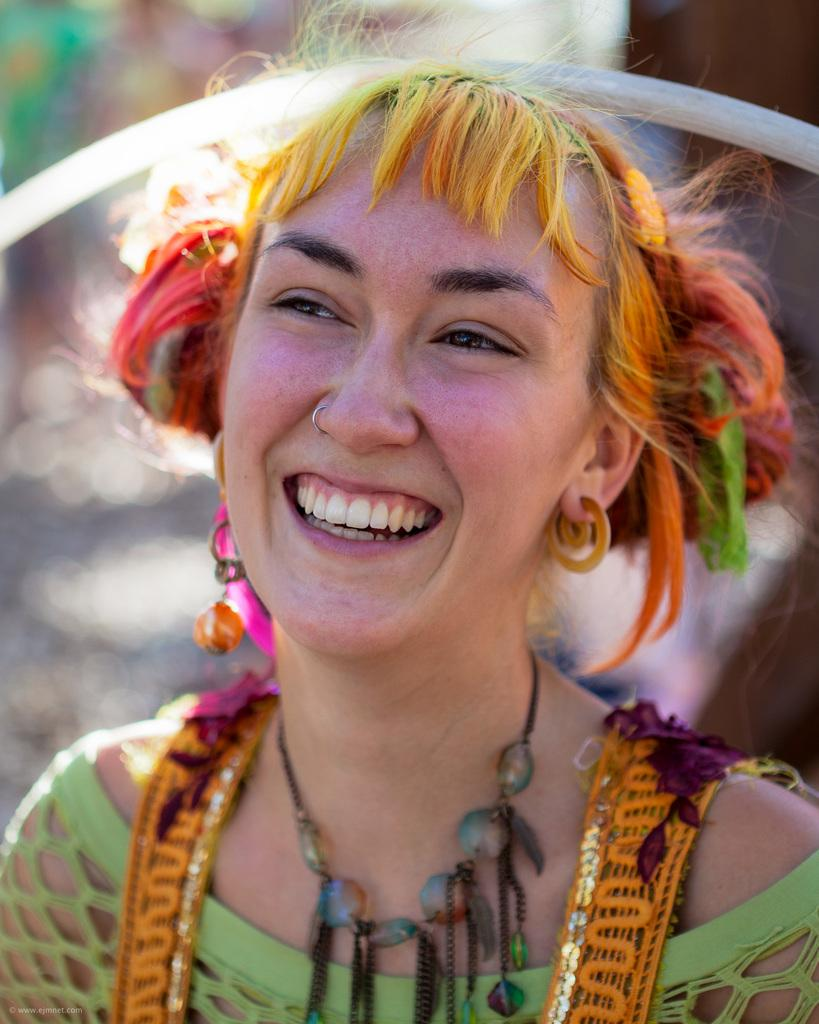Who is present in the image? There is a woman in the image. What is the woman's facial expression? The woman is smiling. What accessory is the woman wearing? The woman is wearing a necklace. Are there any other accessories or clothing items visible on the woman? Yes, there are other objects worn by the woman. Can you describe the background of the image? The background of the image is blurred. What type of cheese is stored in the cellar in the image? There is no cellar or cheese present in the image. What is the woman's opinion on the current political situation in the image? The image does not provide any information about the woman's opinion on the current political situation. 